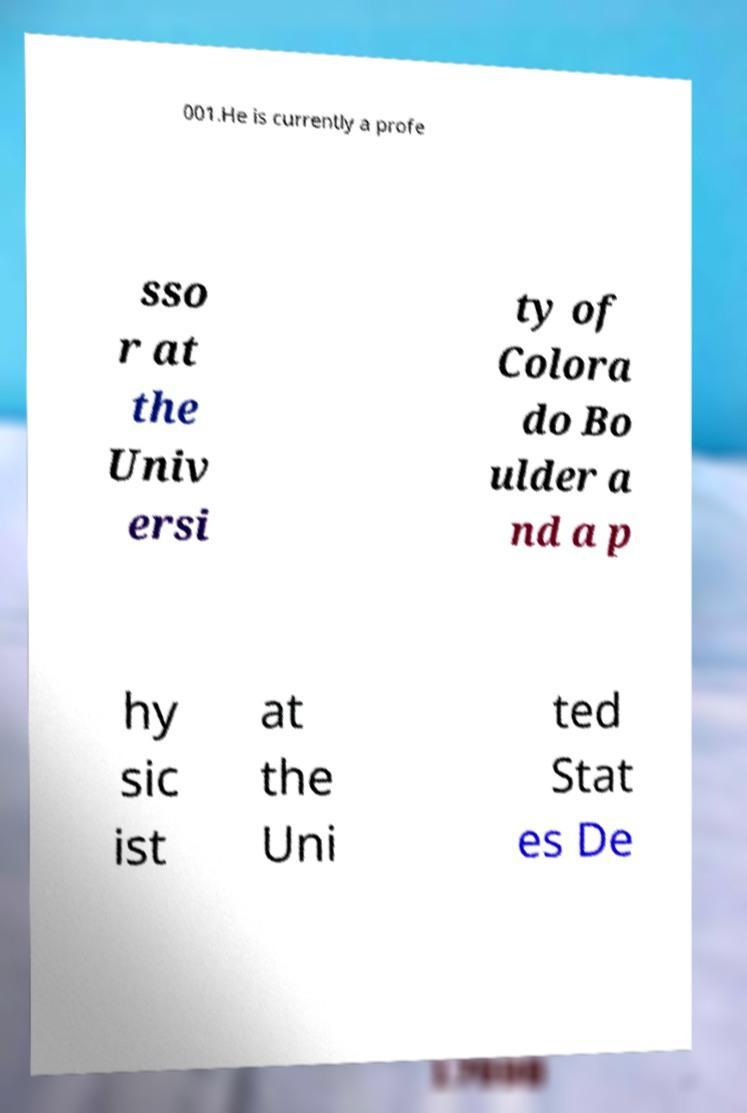Can you read and provide the text displayed in the image?This photo seems to have some interesting text. Can you extract and type it out for me? 001.He is currently a profe sso r at the Univ ersi ty of Colora do Bo ulder a nd a p hy sic ist at the Uni ted Stat es De 